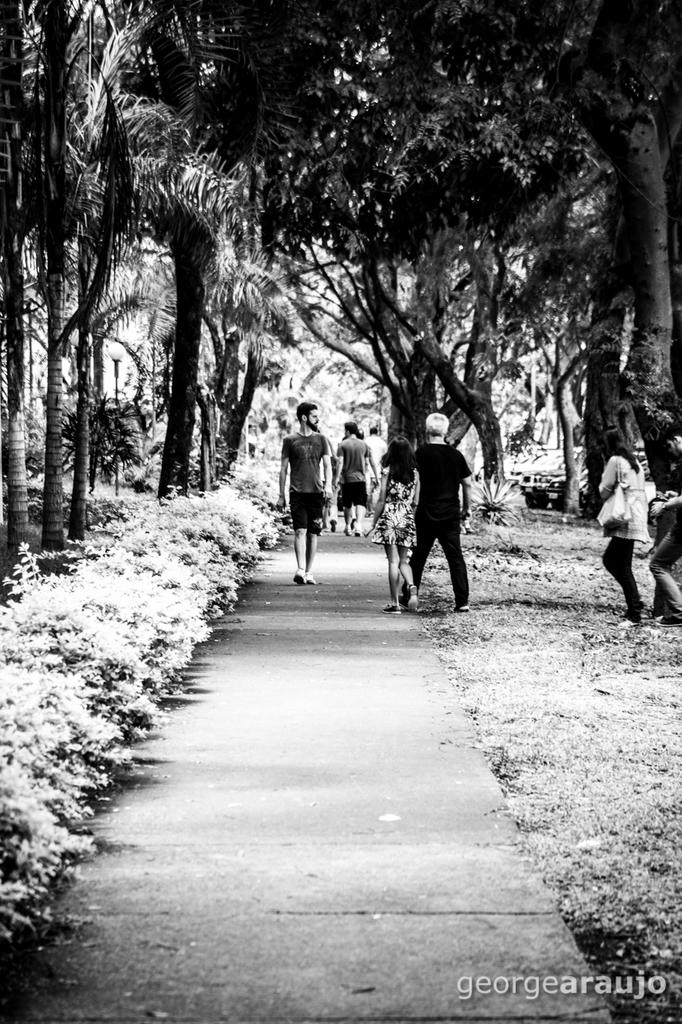Who or what can be seen in the image? There are people in the image. What else is present in the image besides people? There are plants, a vehicle, trees, and a watermark at the bottom of the image. Is there any smoke coming from the vehicle in the image? There is no mention of smoke in the provided facts, and therefore it cannot be determined if there is any smoke coming from the vehicle in the image. 